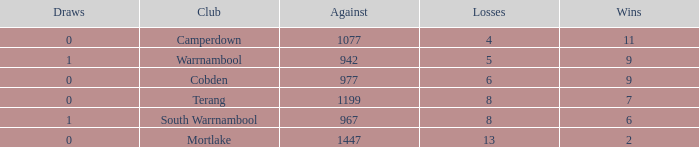What's the number of losses when the wins were more than 11 and had 0 draws? 0.0. 